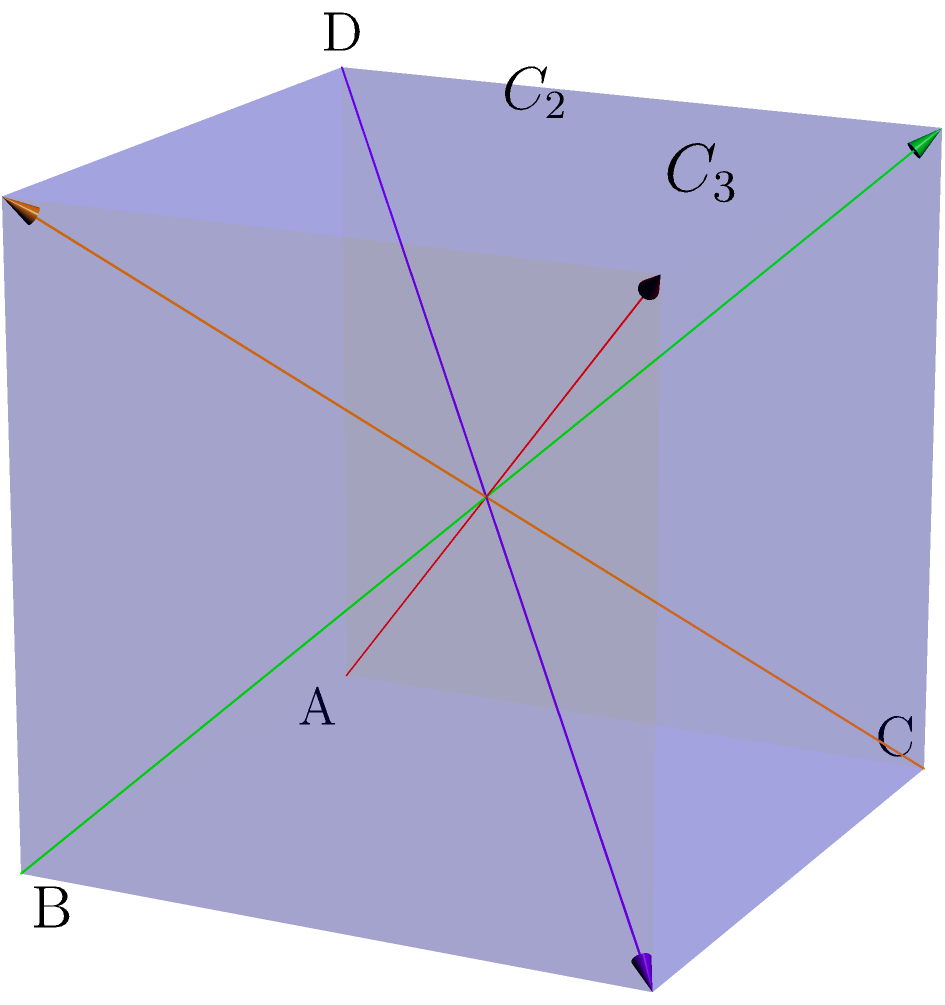In the tetrahedral molecule shown above, identify the number and types of rotation axes present. How does this relate to the symmetry operations in the tetrahedral point group $T_d$? To answer this question, let's analyze the symmetry elements of the tetrahedral molecule step-by-step:

1. Proper rotation axes:
   a) $C_3$ axes: There are four $C_3$ axes, each passing through a vertex and the center of the opposite face. One is shown in red in the diagram.
   b) $C_2$ axes: There are three $C_2$ axes, each passing through the midpoints of opposite edges. One is shown in green in the diagram.

2. Improper rotation axes:
   a) $S_4$ axes: There are three $S_4$ axes, coincident with the $C_2$ axes.

3. Planes of symmetry:
   a) $\sigma_d$ planes: There are six dihedral planes of symmetry, each passing through an edge and bisecting the opposite edge.

4. Point group $T_d$:
   The tetrahedral point group $T_d$ is characterized by these symmetry elements:
   - Four $C_3$ axes
   - Three $C_2$ axes
   - Three $S_4$ axes
   - Six $\sigma_d$ planes
   - Identity operation $E$

5. Relation to symmetry operations:
   Each symmetry element corresponds to specific symmetry operations:
   - $C_3$ axes: 120° rotations
   - $C_2$ axes: 180° rotations
   - $S_4$ axes: 90° rotation followed by reflection in a plane perpendicular to the axis
   - $\sigma_d$ planes: reflections

The tetrahedral molecule possesses all these symmetry elements, which collectively define the $T_d$ point group. This high symmetry is crucial in determining the molecule's properties, including its spectroscopic behavior and reactivity, which are important considerations in pharmaceutical research and drug design.
Answer: 4 $C_3$ axes, 3 $C_2$ axes, 3 $S_4$ axes, 6 $\sigma_d$ planes; consistent with $T_d$ point group 